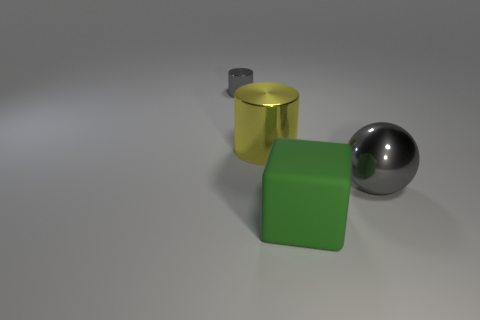Add 1 tiny cylinders. How many objects exist? 5 Subtract all yellow cylinders. How many cylinders are left? 1 Subtract 2 cylinders. How many cylinders are left? 0 Subtract all purple cylinders. How many blue spheres are left? 0 Subtract 0 gray cubes. How many objects are left? 4 Subtract all cubes. How many objects are left? 3 Subtract all purple cylinders. Subtract all red cubes. How many cylinders are left? 2 Subtract all tiny brown metallic cubes. Subtract all tiny gray metal objects. How many objects are left? 3 Add 3 gray cylinders. How many gray cylinders are left? 4 Add 3 large gray metallic things. How many large gray metallic things exist? 4 